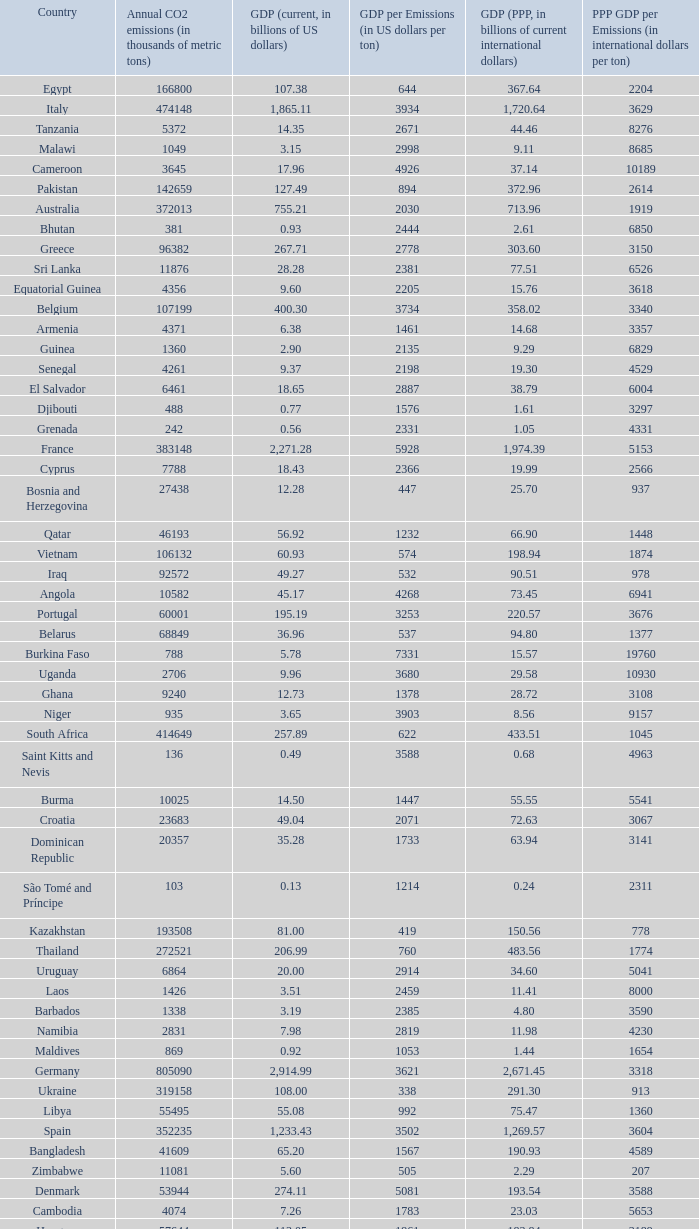When the gdp (ppp, in billions of current international dollars) is 7.93, what is the maximum ppp gdp per emissions (in international dollars per ton)? 9960.0. 